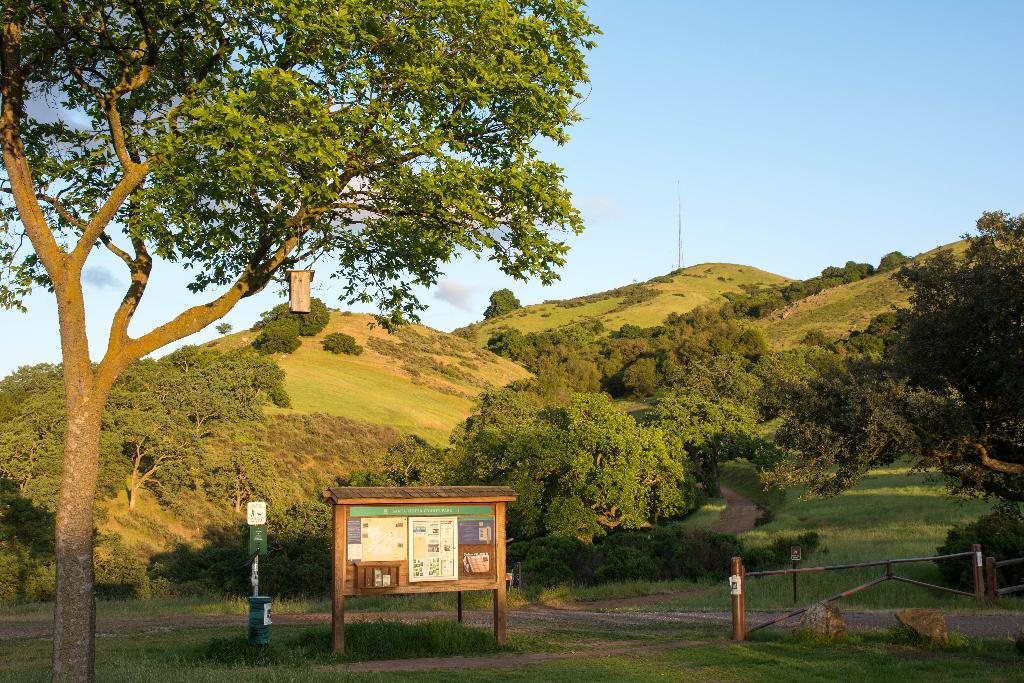What type of material is used for the boards in the image? The wooden boards in the image are made of wood. What is the purpose of the fencing in the image? The fencing in the image is likely used for enclosing or separating areas. What type of natural features can be seen in the image? Trees and mountains are visible in the image. What is the condition of the sky in the image? The top of the image has a clear sky. Where is the crown placed on the gate in the image? There is no crown or gate present in the image. Can you describe the frog sitting on the wooden boards in the image? There is no frog present in the image; it only features wooden boards, fencing, trees, mountains, and a clear sky. 